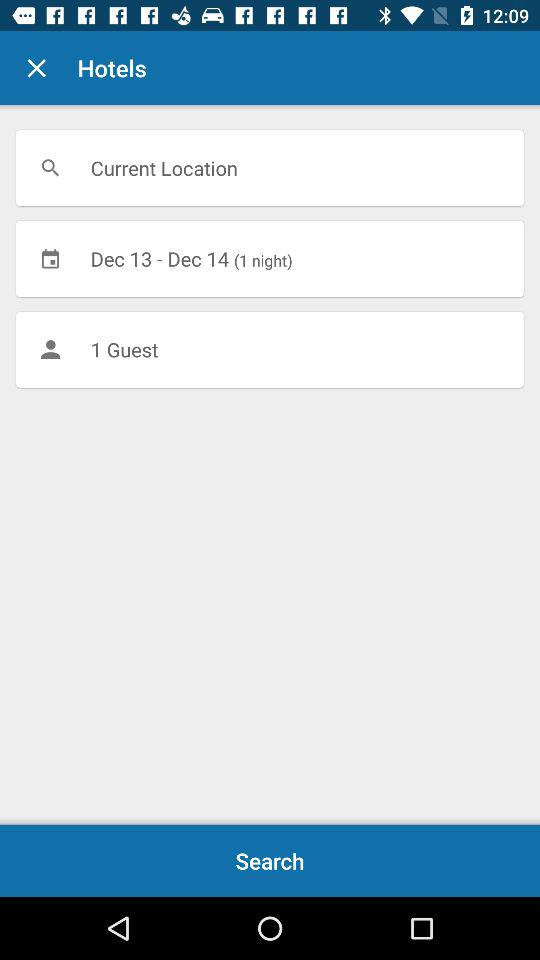What is the number of nights? The number of nights is 1. 